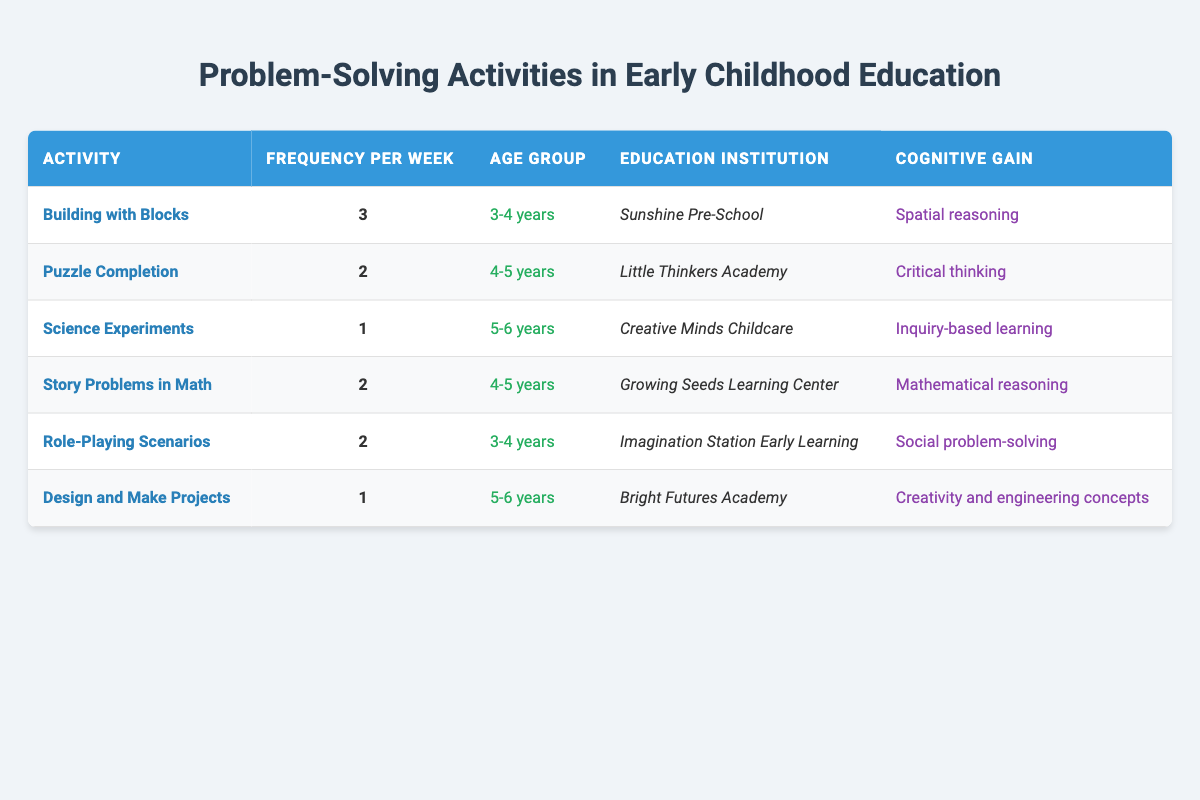What is the frequency of "Building with Blocks" per week? The frequency for "Building with Blocks" is directly listed in the table under the corresponding column. It shows a frequency of 3 per week.
Answer: 3 Which age group participates in "Puzzle Completion"? The age group for "Puzzle Completion" is specified in the table, showing that this activity is intended for children aged 4-5 years.
Answer: 4-5 years How many total problem-solving activities are listed that are conducted weekly? To find the total number, we need to count the number of unique activities listed in the table. There are 6 activities in total.
Answer: 6 Is there an activity that combines creative and engineering concepts for 5-6 year olds? Checking the table for any such activity shows that "Design and Make Projects" is aimed at the 5-6 year age group and focuses on creativity and engineering concepts, therefore the answer is Yes.
Answer: Yes What is the average frequency of problem-solving activities for the 3-4 year age group? First, identify the activities for the 3-4 year age group from the table, which are "Building with Blocks" (3 times a week) and "Role-Playing Scenarios" (2 times a week). Adding these gives 3 + 2 = 5. Then, divide by the number of activities (2) to get the average: 5 / 2 = 2.5.
Answer: 2.5 Which educational institution incorporates "Science Experiments" into their curriculum? The table indicates that "Science Experiments" is offered at "Creative Minds Childcare." This information can be directly retrieved from the corresponding row.
Answer: Creative Minds Childcare Are there more activities that focus on critical thinking than those focusing on spatial reasoning? To answer this, we can compare the activities focusing on critical thinking ("Puzzle Completion") and spatial reasoning ("Building with Blocks"). There is 1 activity for critical thinking and 1 for spatial reasoning, meaning they are equal in number. Thus, the answer to the question is No.
Answer: No What cognitive gain is associated with "Story Problems in Math"? The table specifies that the cognitive gain from "Story Problems in Math" is "Mathematical reasoning," which can be found in the appropriate column for this activity.
Answer: Mathematical reasoning What is the total frequency of problem-solving activities for the age group 5-6 years? By examining the table for the activities associated with the 5-6 year age group ("Science Experiments" at 1 frequency and "Design and Make Projects" at 1 frequency), we can sum these frequencies: 1 + 1 = 2.
Answer: 2 